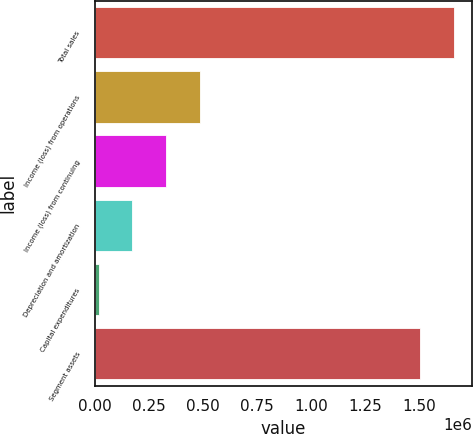<chart> <loc_0><loc_0><loc_500><loc_500><bar_chart><fcel>Total sales<fcel>Income (loss) from operations<fcel>Income (loss) from continuing<fcel>Depreciation and amortization<fcel>Capital expenditures<fcel>Segment assets<nl><fcel>1.66302e+06<fcel>486225<fcel>330722<fcel>175218<fcel>19715<fcel>1.50752e+06<nl></chart> 